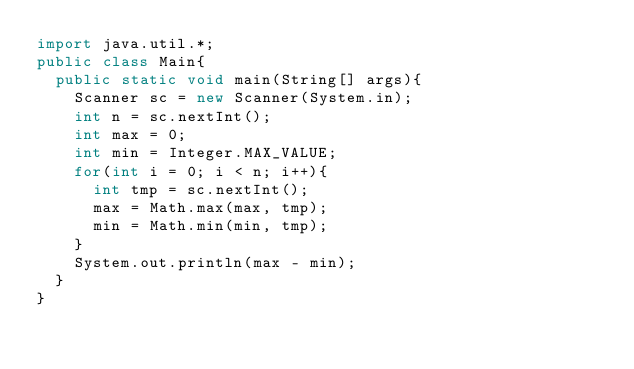Convert code to text. <code><loc_0><loc_0><loc_500><loc_500><_Java_>import java.util.*;
public class Main{
  public static void main(String[] args){
    Scanner sc = new Scanner(System.in);
    int n = sc.nextInt();
    int max = 0;
    int min = Integer.MAX_VALUE;
    for(int i = 0; i < n; i++){
      int tmp = sc.nextInt();
      max = Math.max(max, tmp);
      min = Math.min(min, tmp);
    }
    System.out.println(max - min);
  }
}</code> 